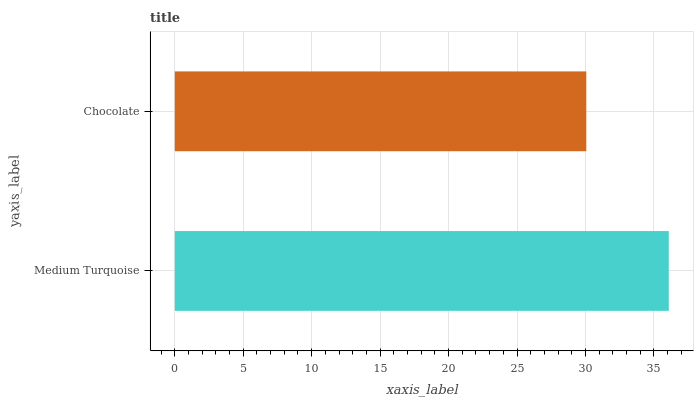Is Chocolate the minimum?
Answer yes or no. Yes. Is Medium Turquoise the maximum?
Answer yes or no. Yes. Is Chocolate the maximum?
Answer yes or no. No. Is Medium Turquoise greater than Chocolate?
Answer yes or no. Yes. Is Chocolate less than Medium Turquoise?
Answer yes or no. Yes. Is Chocolate greater than Medium Turquoise?
Answer yes or no. No. Is Medium Turquoise less than Chocolate?
Answer yes or no. No. Is Medium Turquoise the high median?
Answer yes or no. Yes. Is Chocolate the low median?
Answer yes or no. Yes. Is Chocolate the high median?
Answer yes or no. No. Is Medium Turquoise the low median?
Answer yes or no. No. 